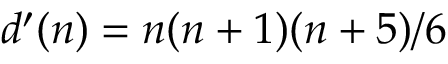Convert formula to latex. <formula><loc_0><loc_0><loc_500><loc_500>d ^ { \prime } ( n ) = n ( n + 1 ) ( n + 5 ) / 6</formula> 